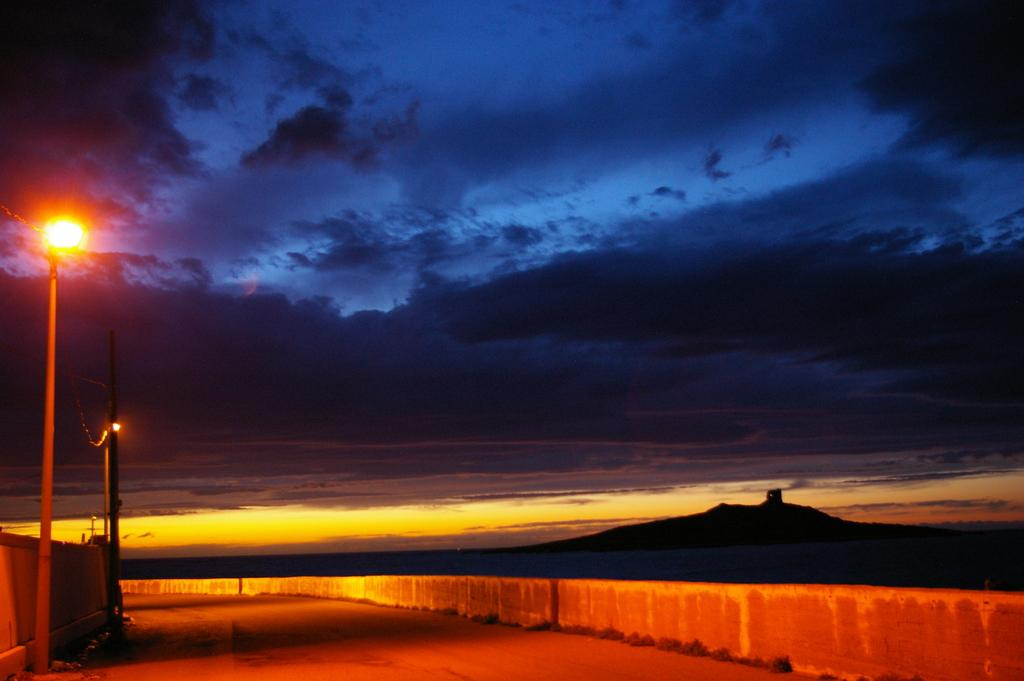What type of surface can be seen in the image? There is a road in the image. What type of vegetation is present in the image? There is grass in the image. What type of structures can be seen in the image? There are walls in the image. What type of man-made objects are present in the image? There are light poles in the image. What type of natural feature is visible in the image? There is a mountain in the image. What is visible in the background of the image? The sky is visible in the background of the image, and there are clouds in the sky. What is the weight of the grain in the image? There is no grain present in the image, so it is not possible to determine its weight. What idea is being conveyed by the light poles in the image? The light poles in the image are not conveying any specific idea; they are simply providing illumination along the road. 